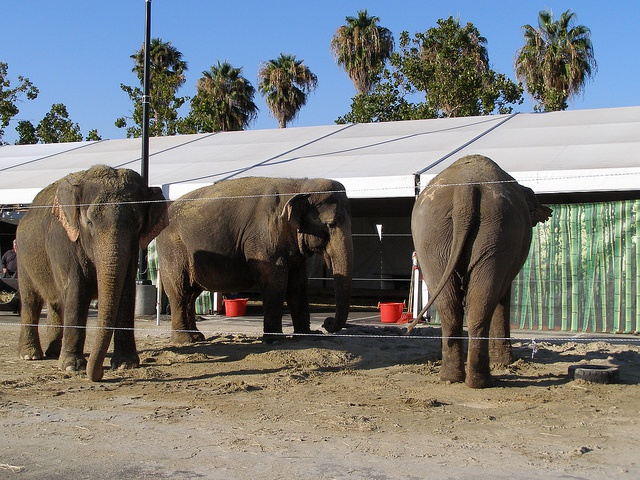Describe the objects in this image and their specific colors. I can see elephant in lightblue, black, gray, and maroon tones, elephant in lightblue, black, and gray tones, elephant in lightblue, black, and gray tones, and people in lightblue, black, gray, and brown tones in this image. 